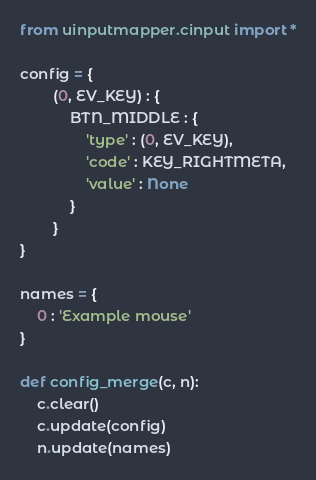<code> <loc_0><loc_0><loc_500><loc_500><_Python_>from uinputmapper.cinput import *

config = {
        (0, EV_KEY) : {
            BTN_MIDDLE : {
                'type' : (0, EV_KEY),
                'code' : KEY_RIGHTMETA,
                'value' : None
            }
        }
}

names = {
    0 : 'Example mouse'
}

def config_merge(c, n):
    c.clear()
    c.update(config)
    n.update(names)
</code> 